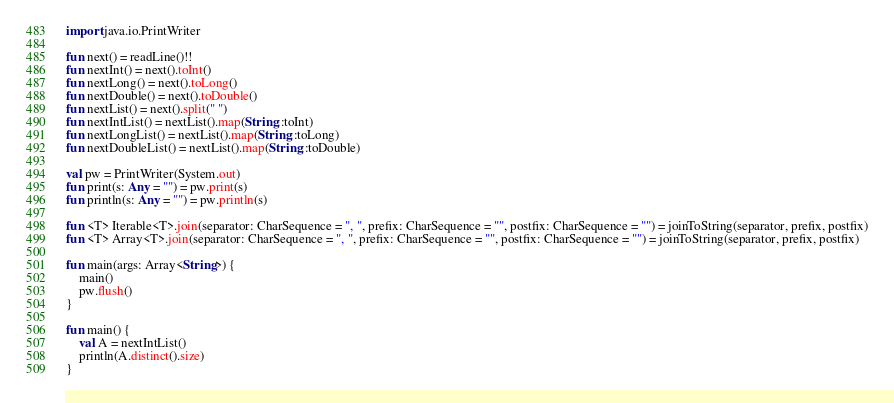Convert code to text. <code><loc_0><loc_0><loc_500><loc_500><_Kotlin_>import java.io.PrintWriter

fun next() = readLine()!!
fun nextInt() = next().toInt()
fun nextLong() = next().toLong()
fun nextDouble() = next().toDouble()
fun nextList() = next().split(" ")
fun nextIntList() = nextList().map(String::toInt)
fun nextLongList() = nextList().map(String::toLong)
fun nextDoubleList() = nextList().map(String::toDouble)

val pw = PrintWriter(System.out)
fun print(s: Any = "") = pw.print(s)
fun println(s: Any = "") = pw.println(s)

fun <T> Iterable<T>.join(separator: CharSequence = ", ", prefix: CharSequence = "", postfix: CharSequence = "") = joinToString(separator, prefix, postfix)
fun <T> Array<T>.join(separator: CharSequence = ", ", prefix: CharSequence = "", postfix: CharSequence = "") = joinToString(separator, prefix, postfix)

fun main(args: Array<String>) {
    main()
    pw.flush()
}

fun main() {
    val A = nextIntList()
    println(A.distinct().size)
}</code> 